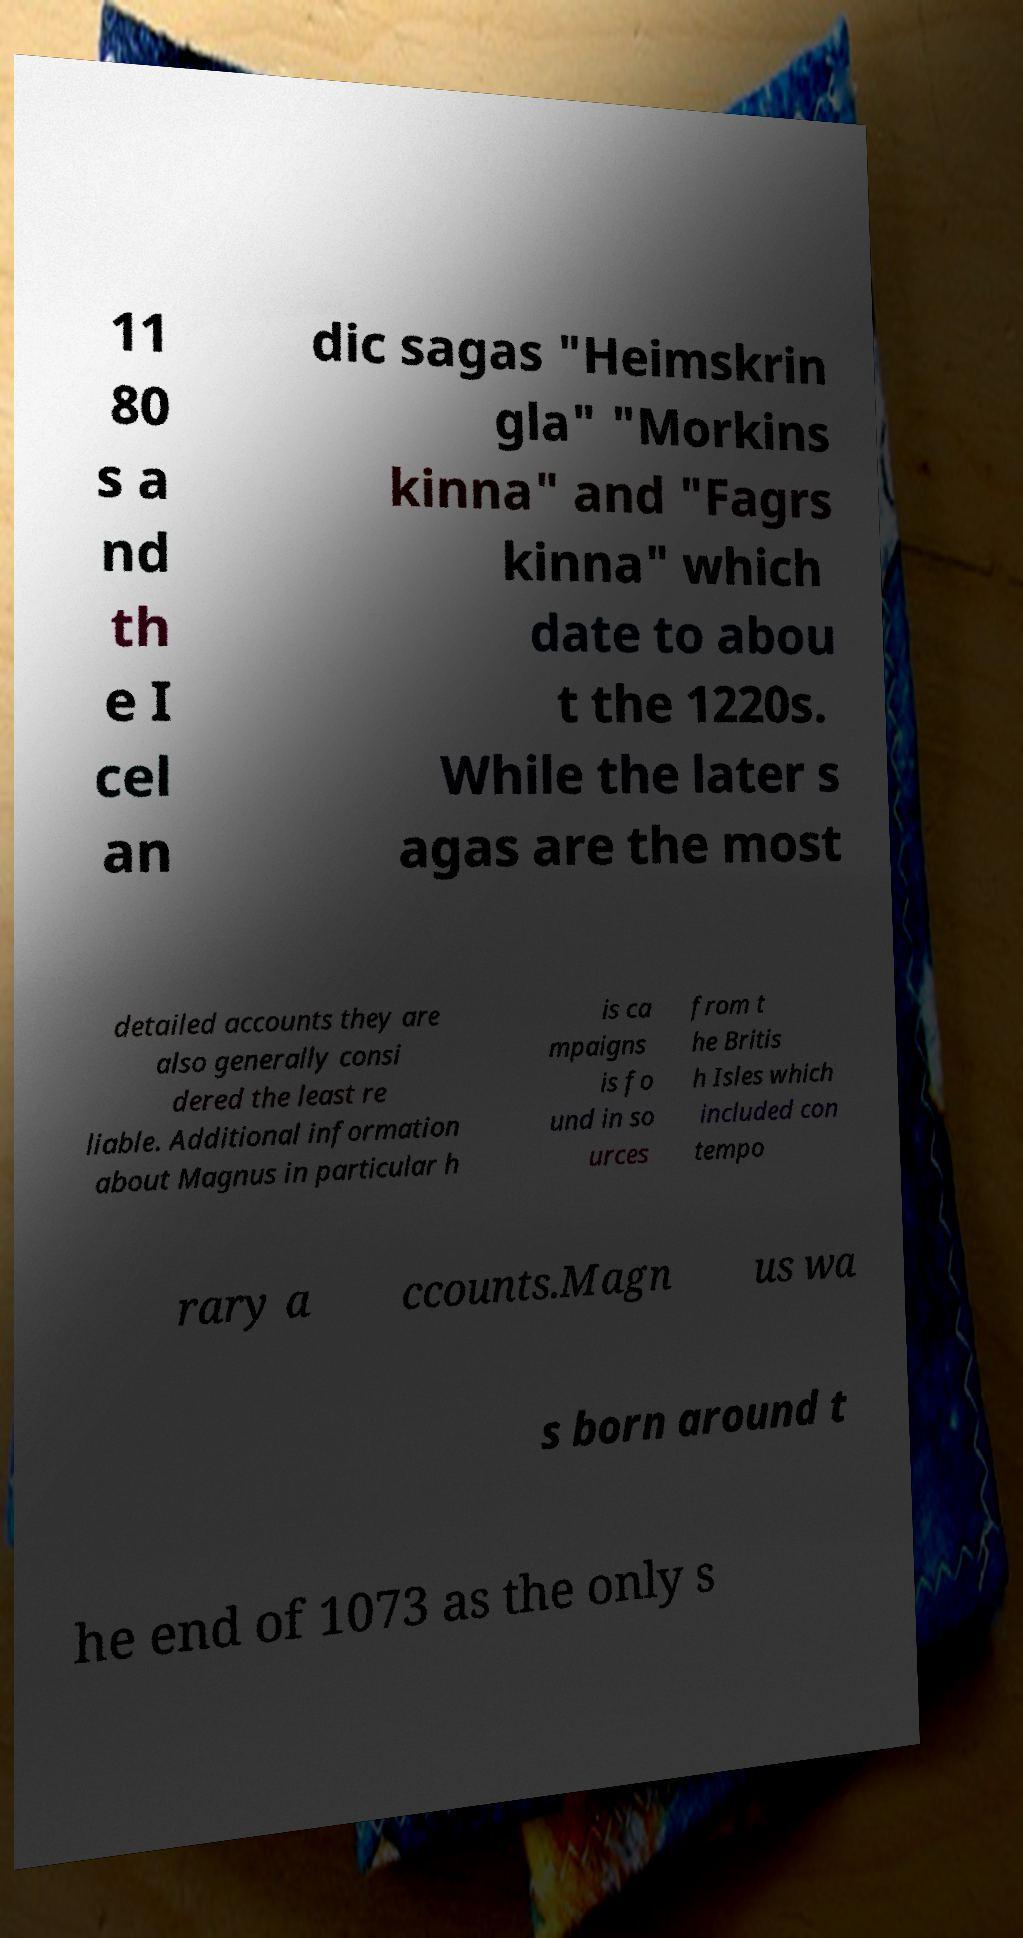For documentation purposes, I need the text within this image transcribed. Could you provide that? 11 80 s a nd th e I cel an dic sagas "Heimskrin gla" "Morkins kinna" and "Fagrs kinna" which date to abou t the 1220s. While the later s agas are the most detailed accounts they are also generally consi dered the least re liable. Additional information about Magnus in particular h is ca mpaigns is fo und in so urces from t he Britis h Isles which included con tempo rary a ccounts.Magn us wa s born around t he end of 1073 as the only s 